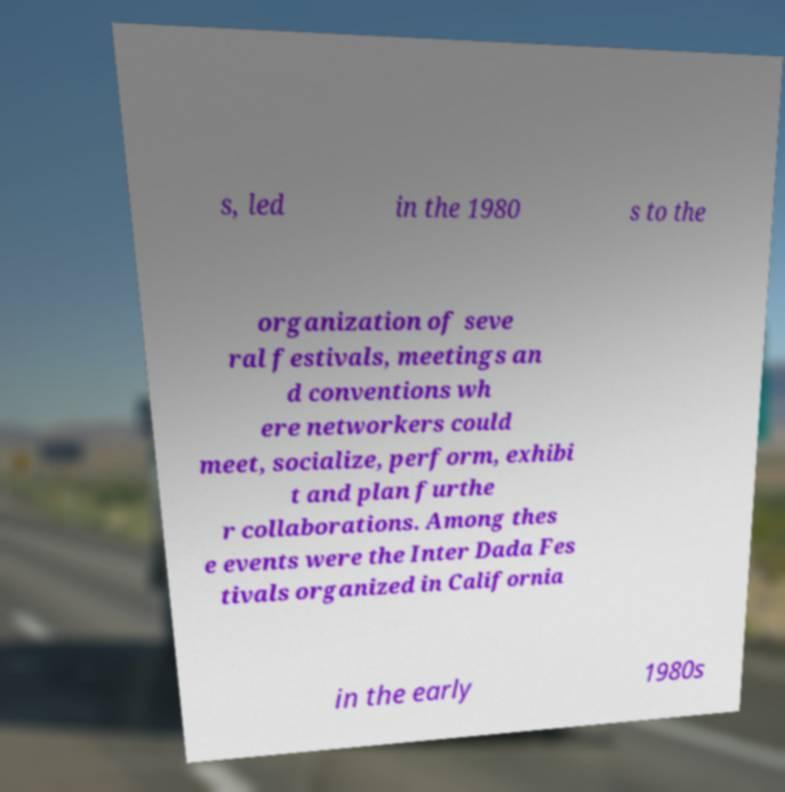There's text embedded in this image that I need extracted. Can you transcribe it verbatim? s, led in the 1980 s to the organization of seve ral festivals, meetings an d conventions wh ere networkers could meet, socialize, perform, exhibi t and plan furthe r collaborations. Among thes e events were the Inter Dada Fes tivals organized in California in the early 1980s 